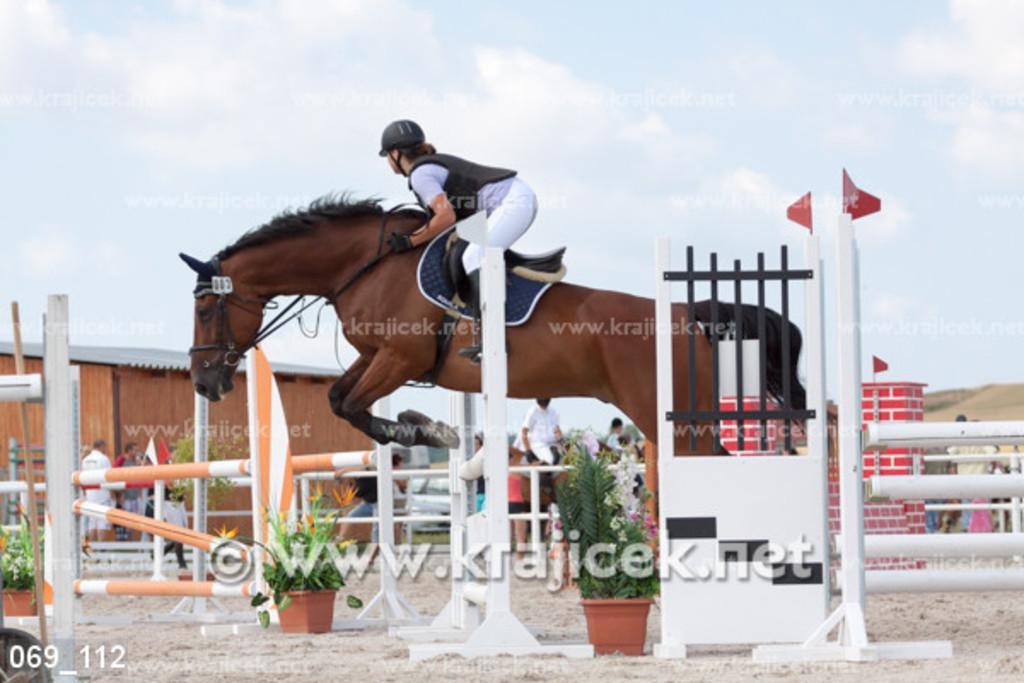How would you summarize this image in a sentence or two? In this image we can see a person riding a horse, there are some potted plants, poles, people, flags, vehicle and a shed, in the background we can see the sky. 